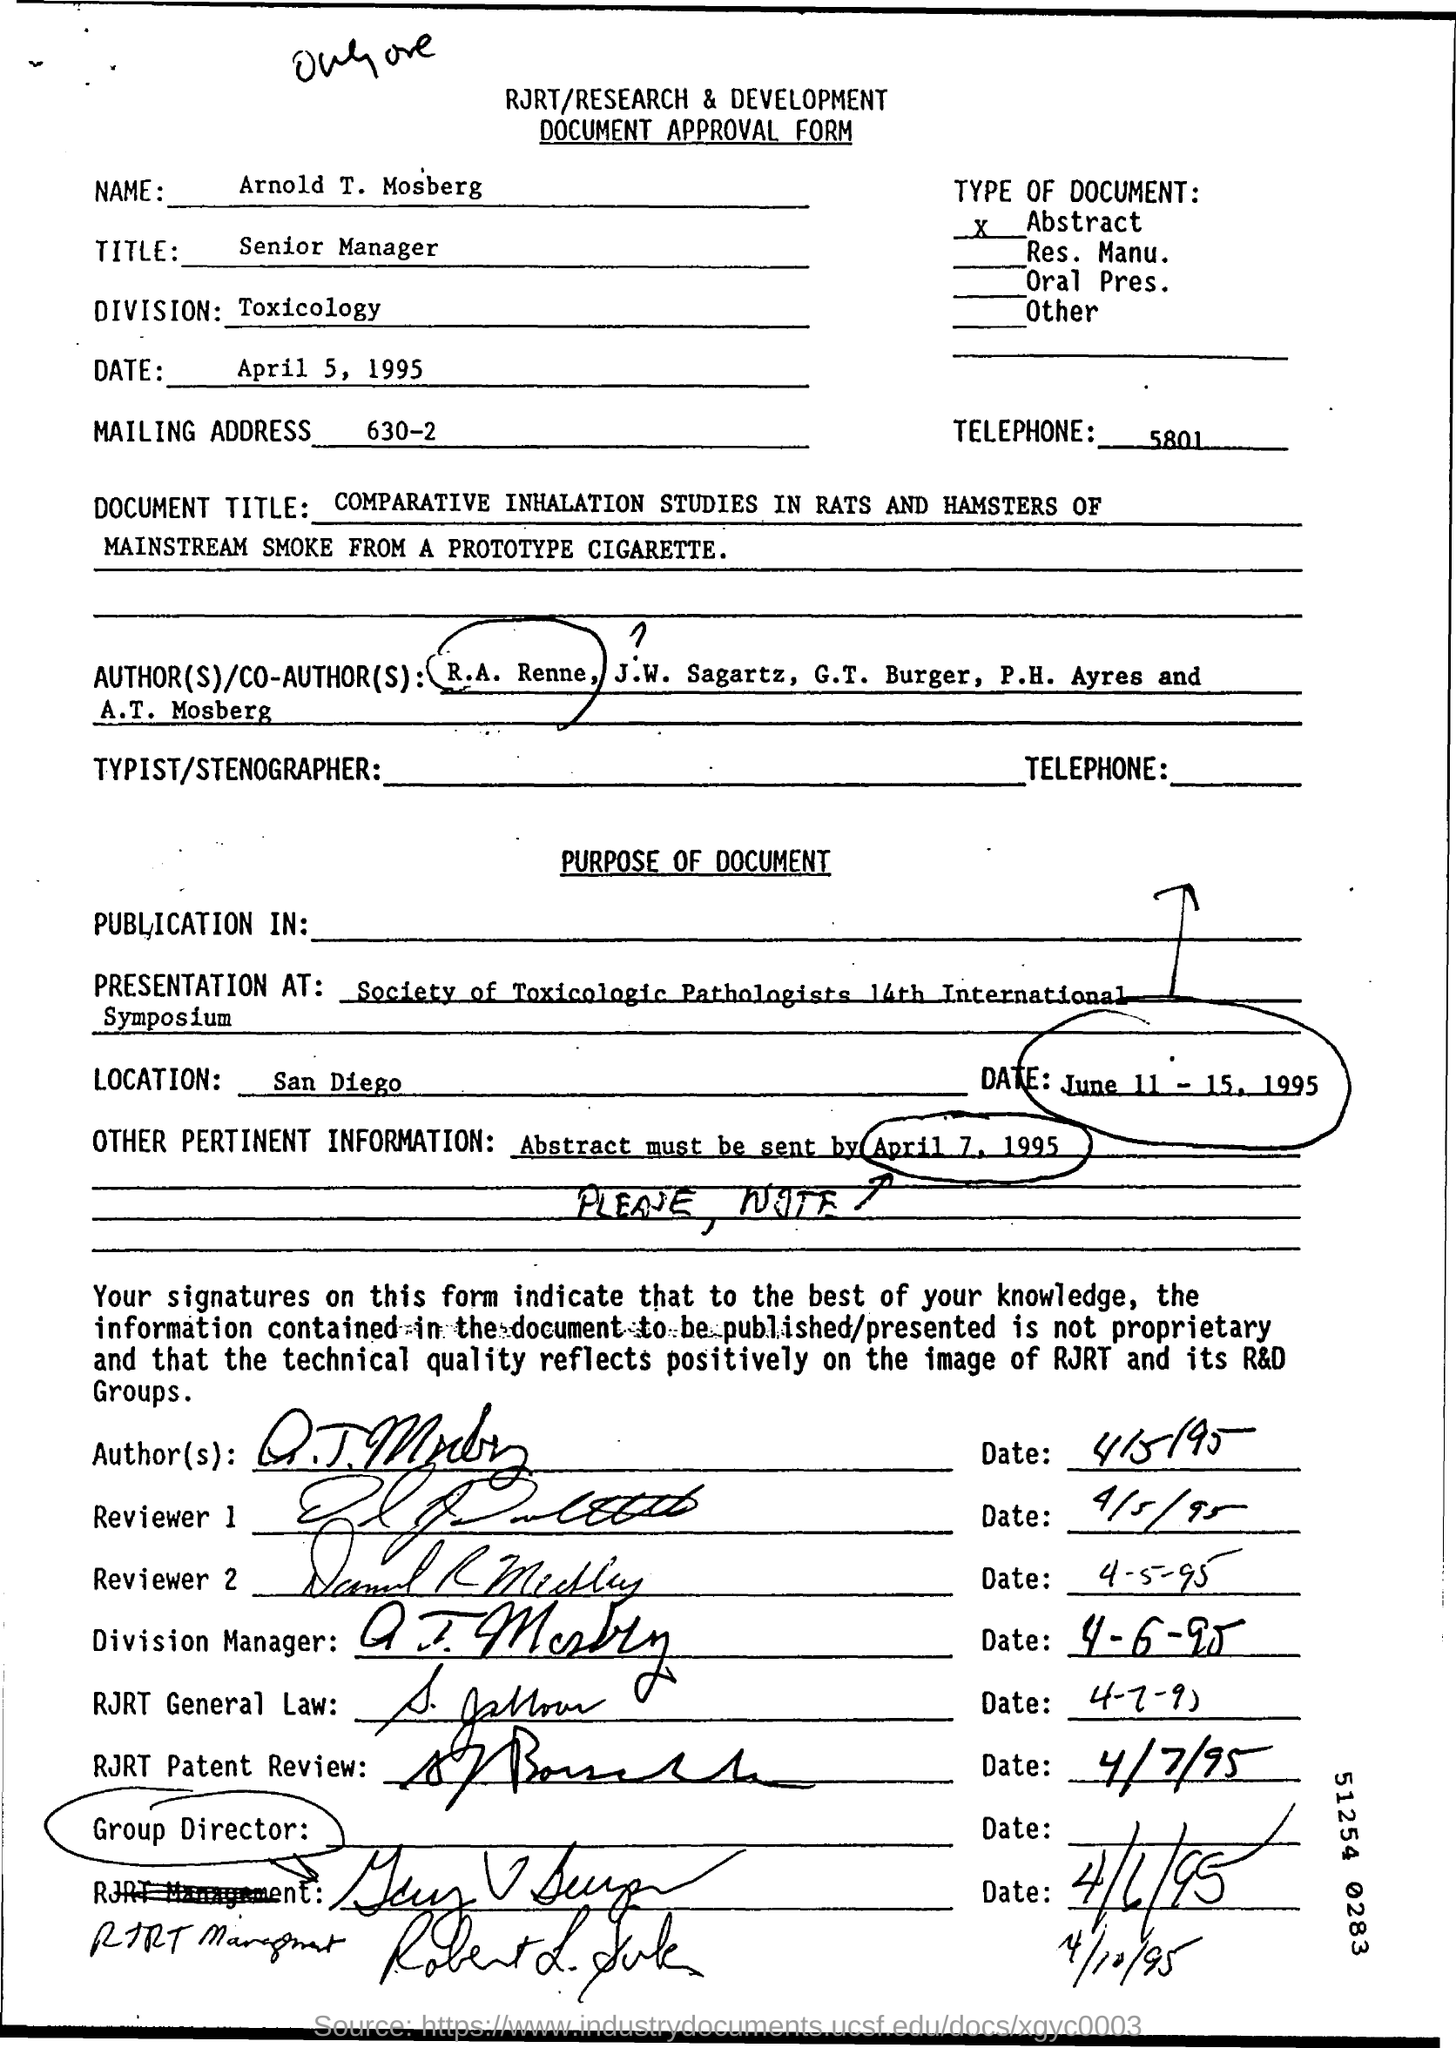What is the name in the Document Approval form?
Your answer should be very brief. Arnold T. Mosberg. What is the title of Arnold?
Offer a very short reply. Senior Manager. Which is the date of the approval form?
Give a very brief answer. April 5, 1995. 